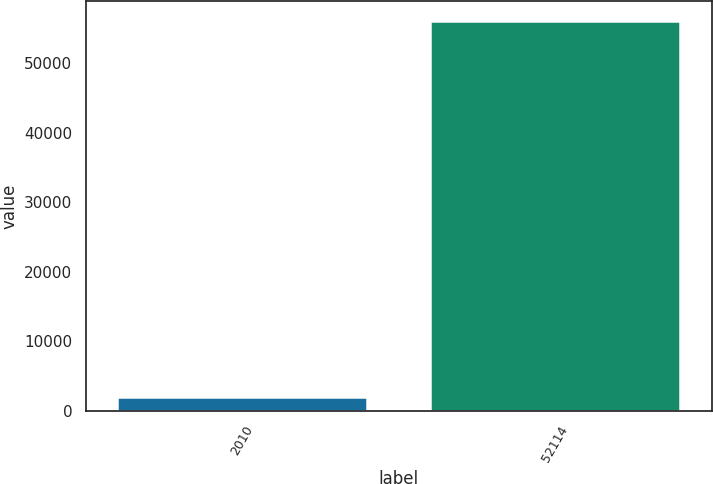Convert chart. <chart><loc_0><loc_0><loc_500><loc_500><bar_chart><fcel>2010<fcel>52114<nl><fcel>2012<fcel>56130<nl></chart> 